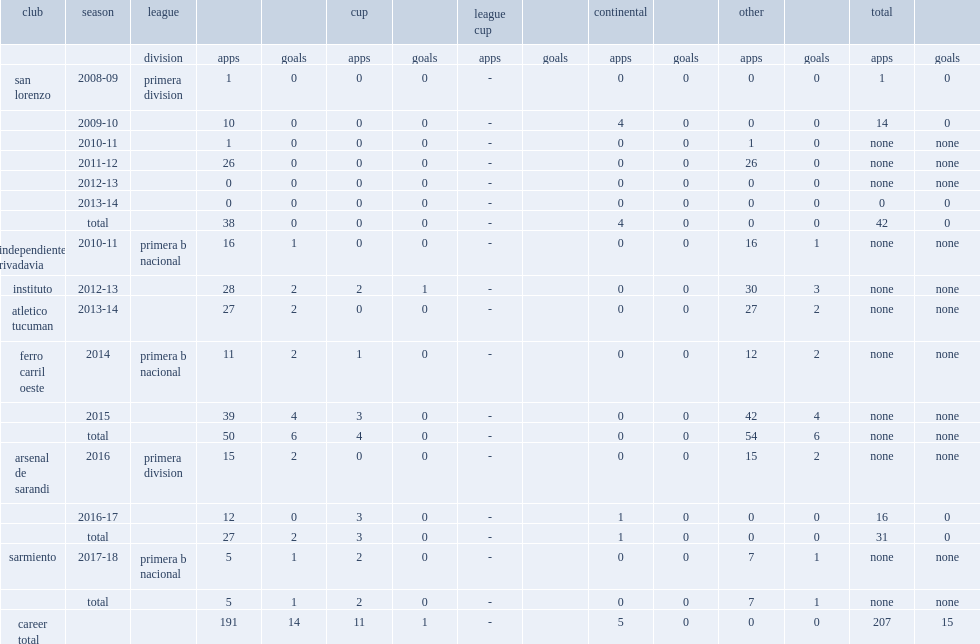Which club did gonzalo bazan play for in 2014? Ferro carril oeste. 